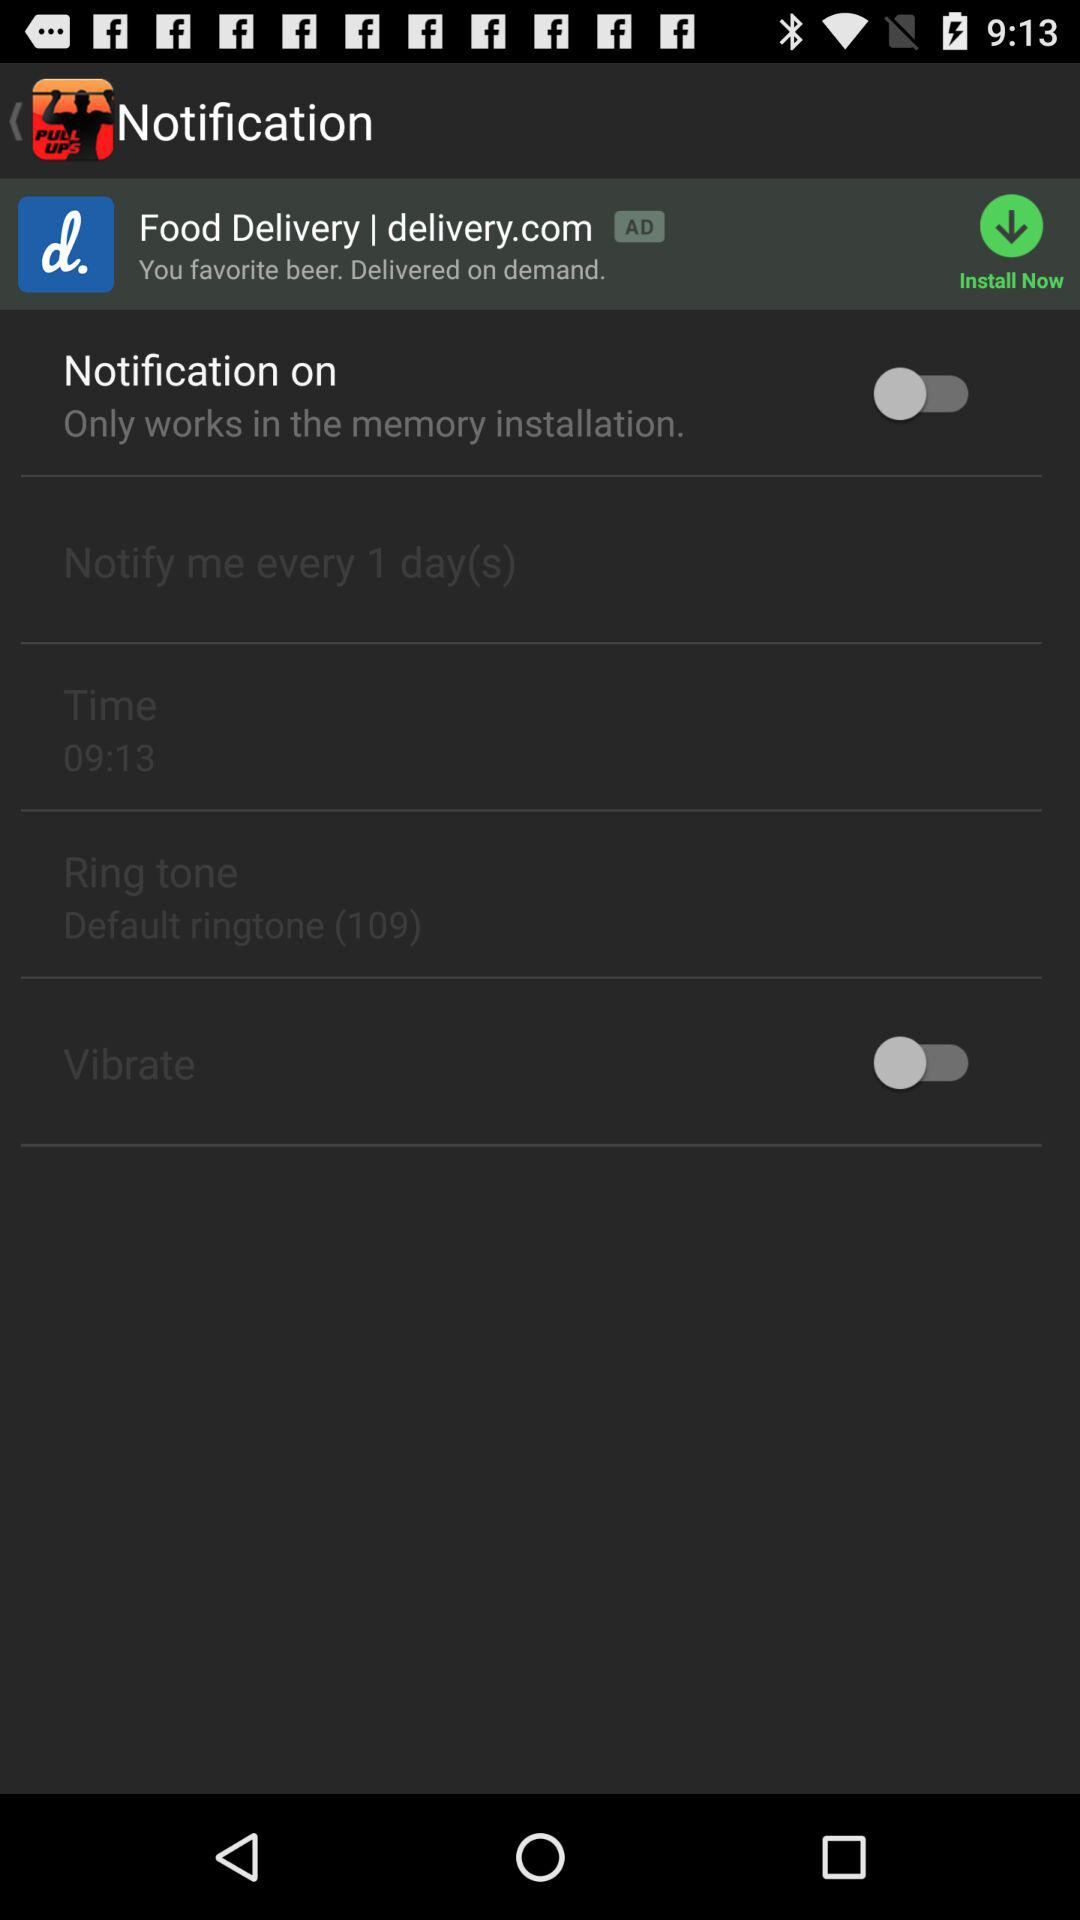What is the time? The time is 09:13. 